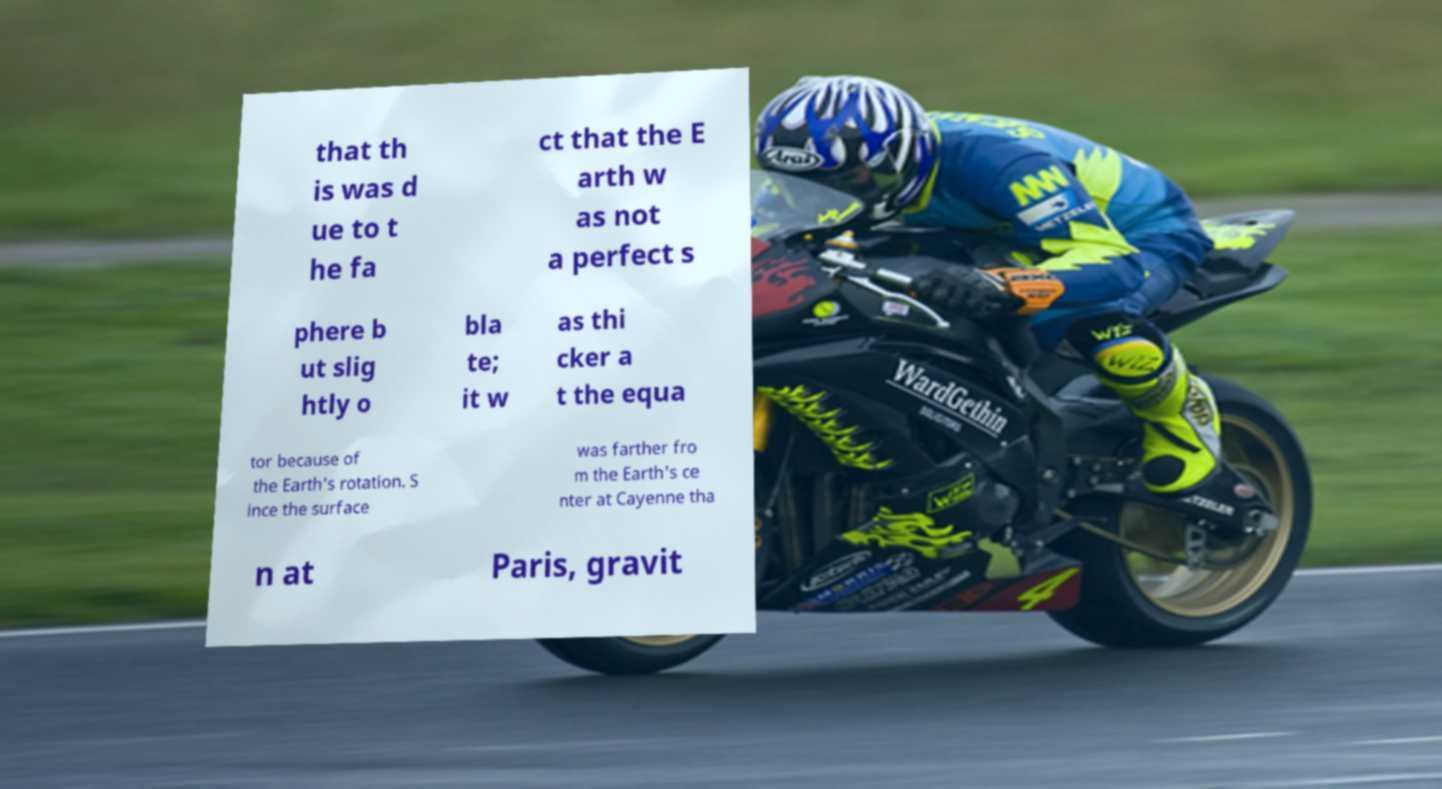There's text embedded in this image that I need extracted. Can you transcribe it verbatim? that th is was d ue to t he fa ct that the E arth w as not a perfect s phere b ut slig htly o bla te; it w as thi cker a t the equa tor because of the Earth's rotation. S ince the surface was farther fro m the Earth's ce nter at Cayenne tha n at Paris, gravit 